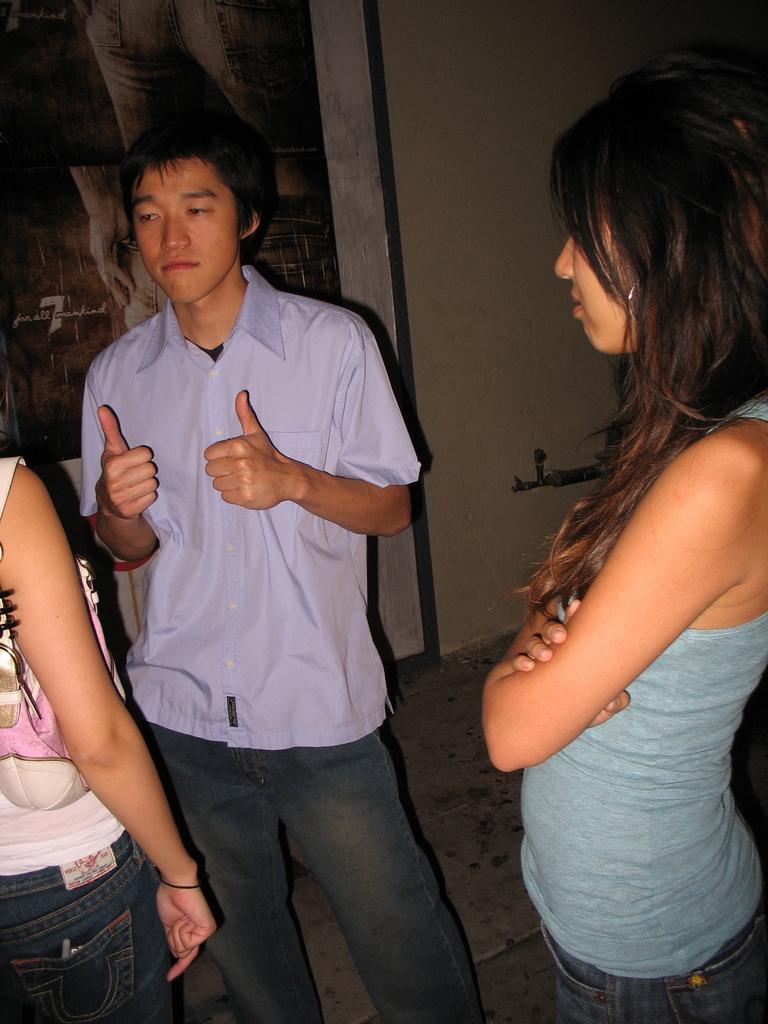Please provide a concise description of this image. In the image we can see three people standing and wearing clothes. We can see the floor and the wall. 